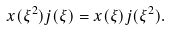Convert formula to latex. <formula><loc_0><loc_0><loc_500><loc_500>x ( { \xi } ^ { 2 } ) j ( \xi ) = x ( \xi ) j ( { \xi } ^ { 2 } ) .</formula> 